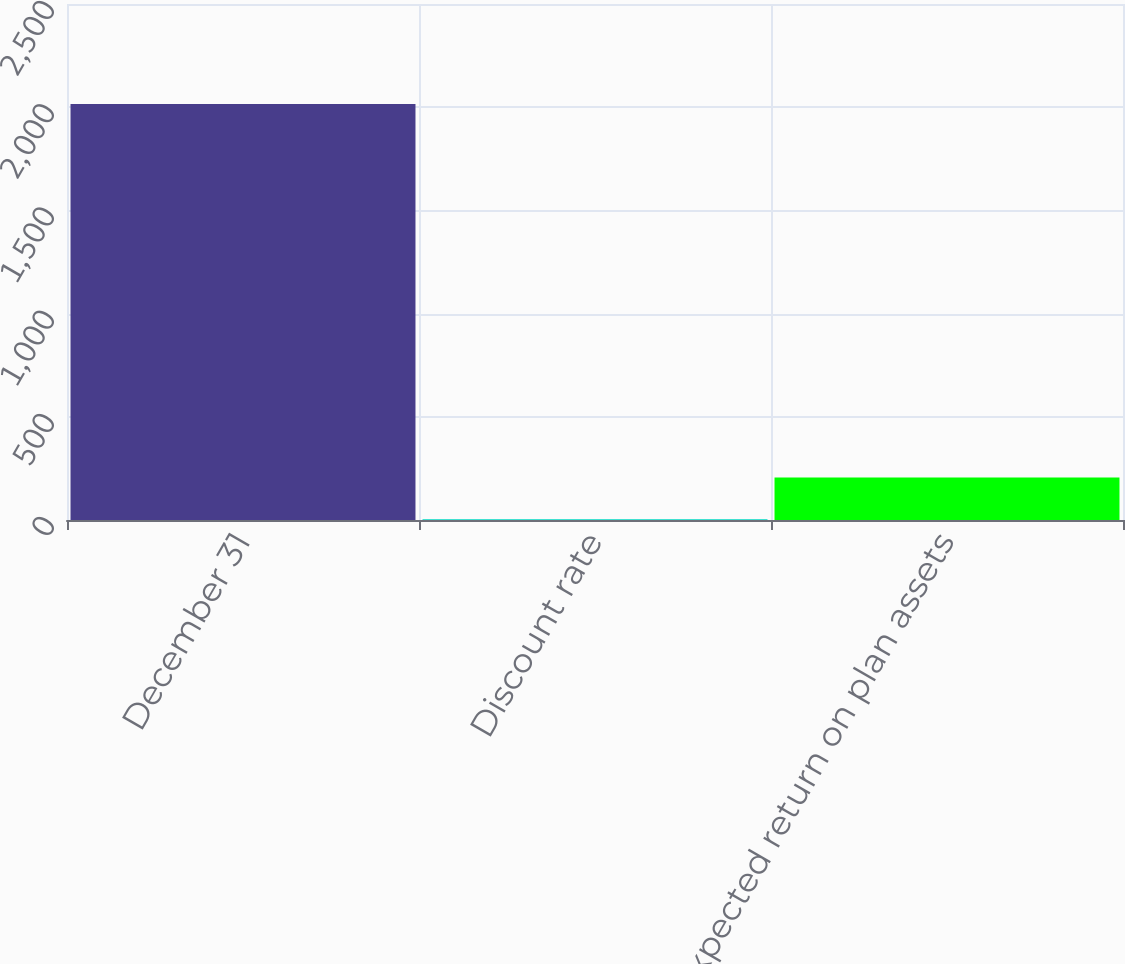Convert chart. <chart><loc_0><loc_0><loc_500><loc_500><bar_chart><fcel>December 31<fcel>Discount rate<fcel>Expected return on plan assets<nl><fcel>2015<fcel>4.26<fcel>205.33<nl></chart> 